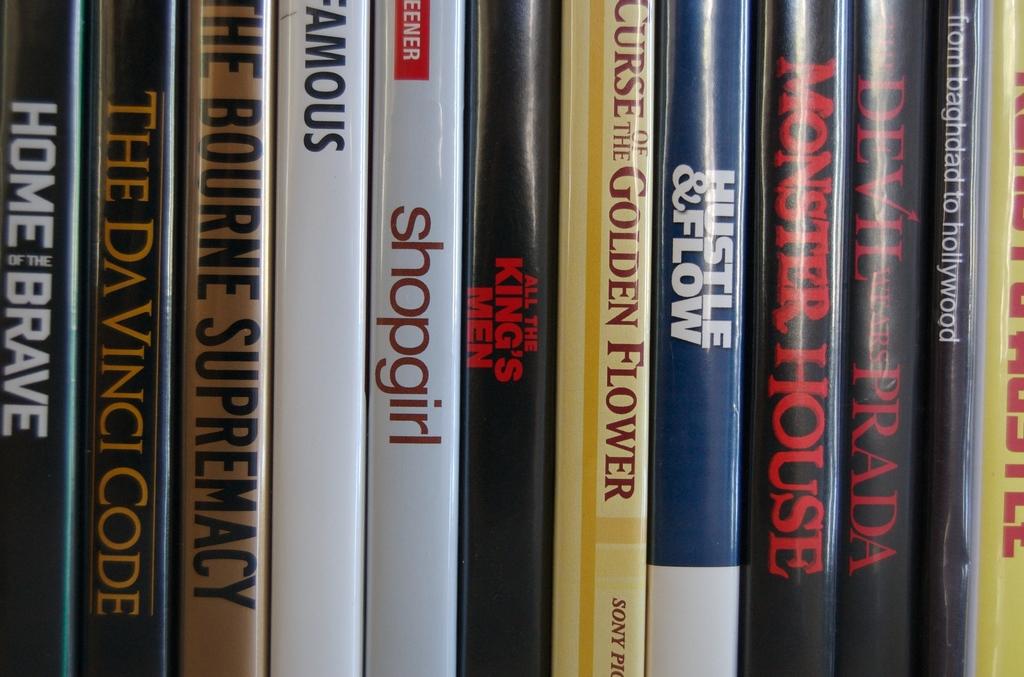What is the title of the movie in brown?
Ensure brevity in your answer.  The bourne supremacy. 